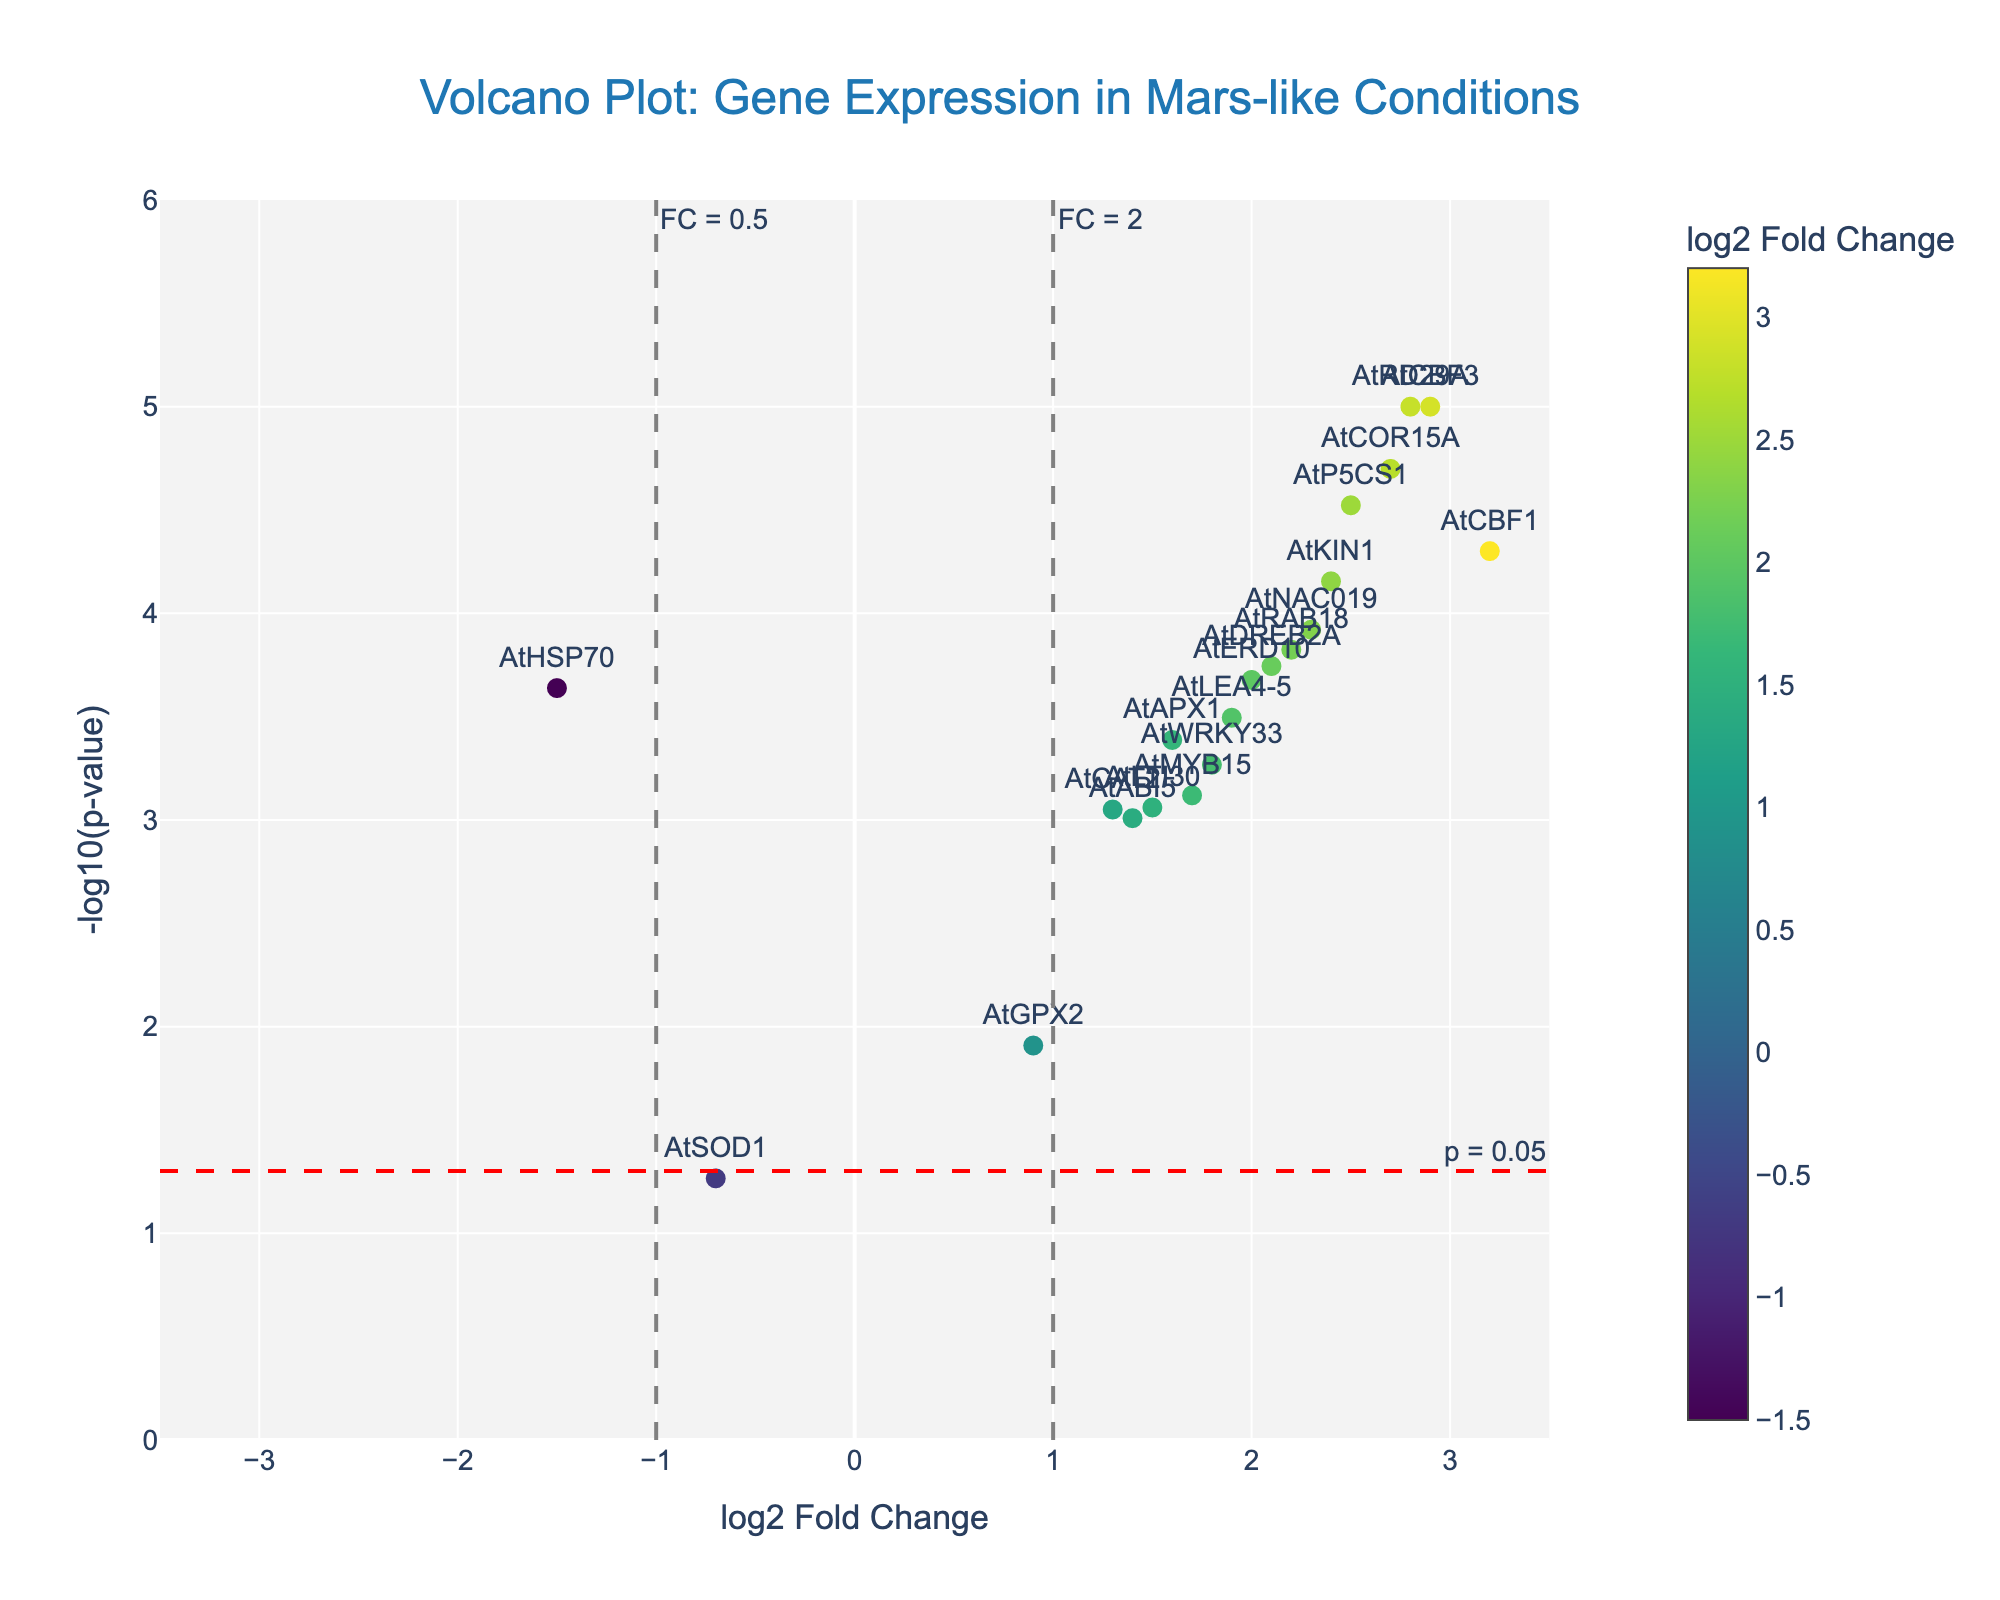How many genes show a negative log2 fold change? First, identify the genes with a negative log2 fold change by observing the x-axis values to the left of zero. AtHSP70 (-1.5) and AtSOD1 (-0.7) are the two genes that meet this criterion.
Answer: 2 Which gene has the highest log2 fold change? To find the highest log2 fold change, look for the data point farthest to the right on the x-axis. AtCBF1 (3.2) is the gene with the highest log2 fold change.
Answer: AtCBF1 What is the log2 fold change value of AtDREB2A? Locate the AtDREB2A data point on the plot and note the x-axis value it aligns with. The log2 fold change for AtDREB2A is 2.1.
Answer: 2.1 How many genes have a p-value less than 0.05? Genes with a p-value less than 0.05 are above the horizontal line drawn at -log10(0.05). Count the data points above this threshold line. There are 17 genes with a p-value less than 0.05.
Answer: 17 Which gene is closest to the p-value threshold of 0.05? To identify the gene nearest the p-value threshold, look at the data points close to the horizontal line at -log10(0.05). AtSOD1 (p-value of 0.05421) is the closest.
Answer: AtSOD1 Which gene shows the most significant level of differential expression? The gene with the lowest p-value has the highest -log10(p-value). AtRD29A and AtCBF3 both show a -log10(p-value) of 5. This means they have the most significant differential expression.
Answer: AtRD29A and AtCBF3 What is the range of log2 fold change values depicted in this plot? The x-axis of the plot ranges from around -3.5 to 3.5. This is deduced by checking the minimum and maximum x-axis limits provided in the instructions.
Answer: -3.5 to 3.5 Which gene has a log2 fold change of approximately 1.5 and a p-value below 0.001? Find the gene near a log2 fold change of 1.5 on the x-axis and above -log10(0.001) (y ~ 3) on the y-axis. AtMYB15 satisfies both criteria.
Answer: AtMYB15 How many genes have a log2 fold change greater than 2 and significant p-values? Look for genes where log2 fold change > 2 (>1 to the right on the x-axis) and p-value < 0.05 (above the horizontal threshold line). There are 9 such genes.
Answer: 9 